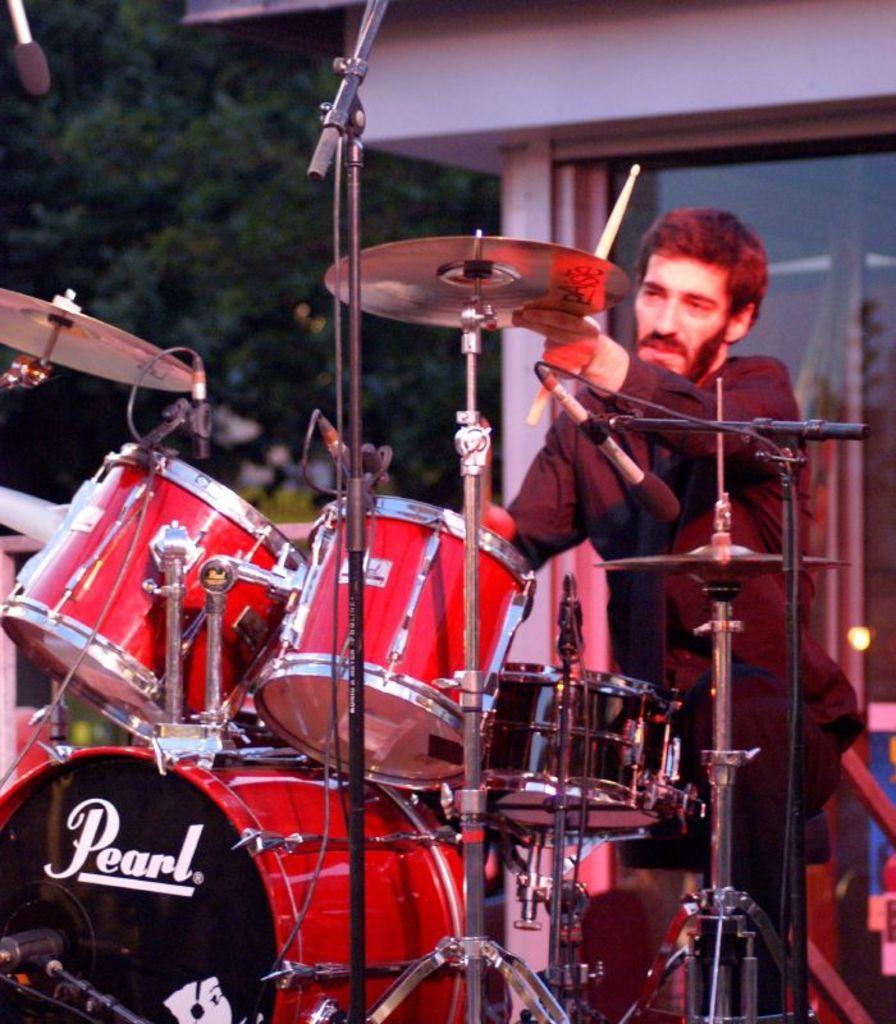How would you summarize this image in a sentence or two? In this picture, we see the man is sitting on the chair and he is holding the sticks in his hands. In front of him, we see the musical instruments. I think he is playing the drums. Behind him, we see a building in white color. It has the glass windows. In the background, we see the trees. 